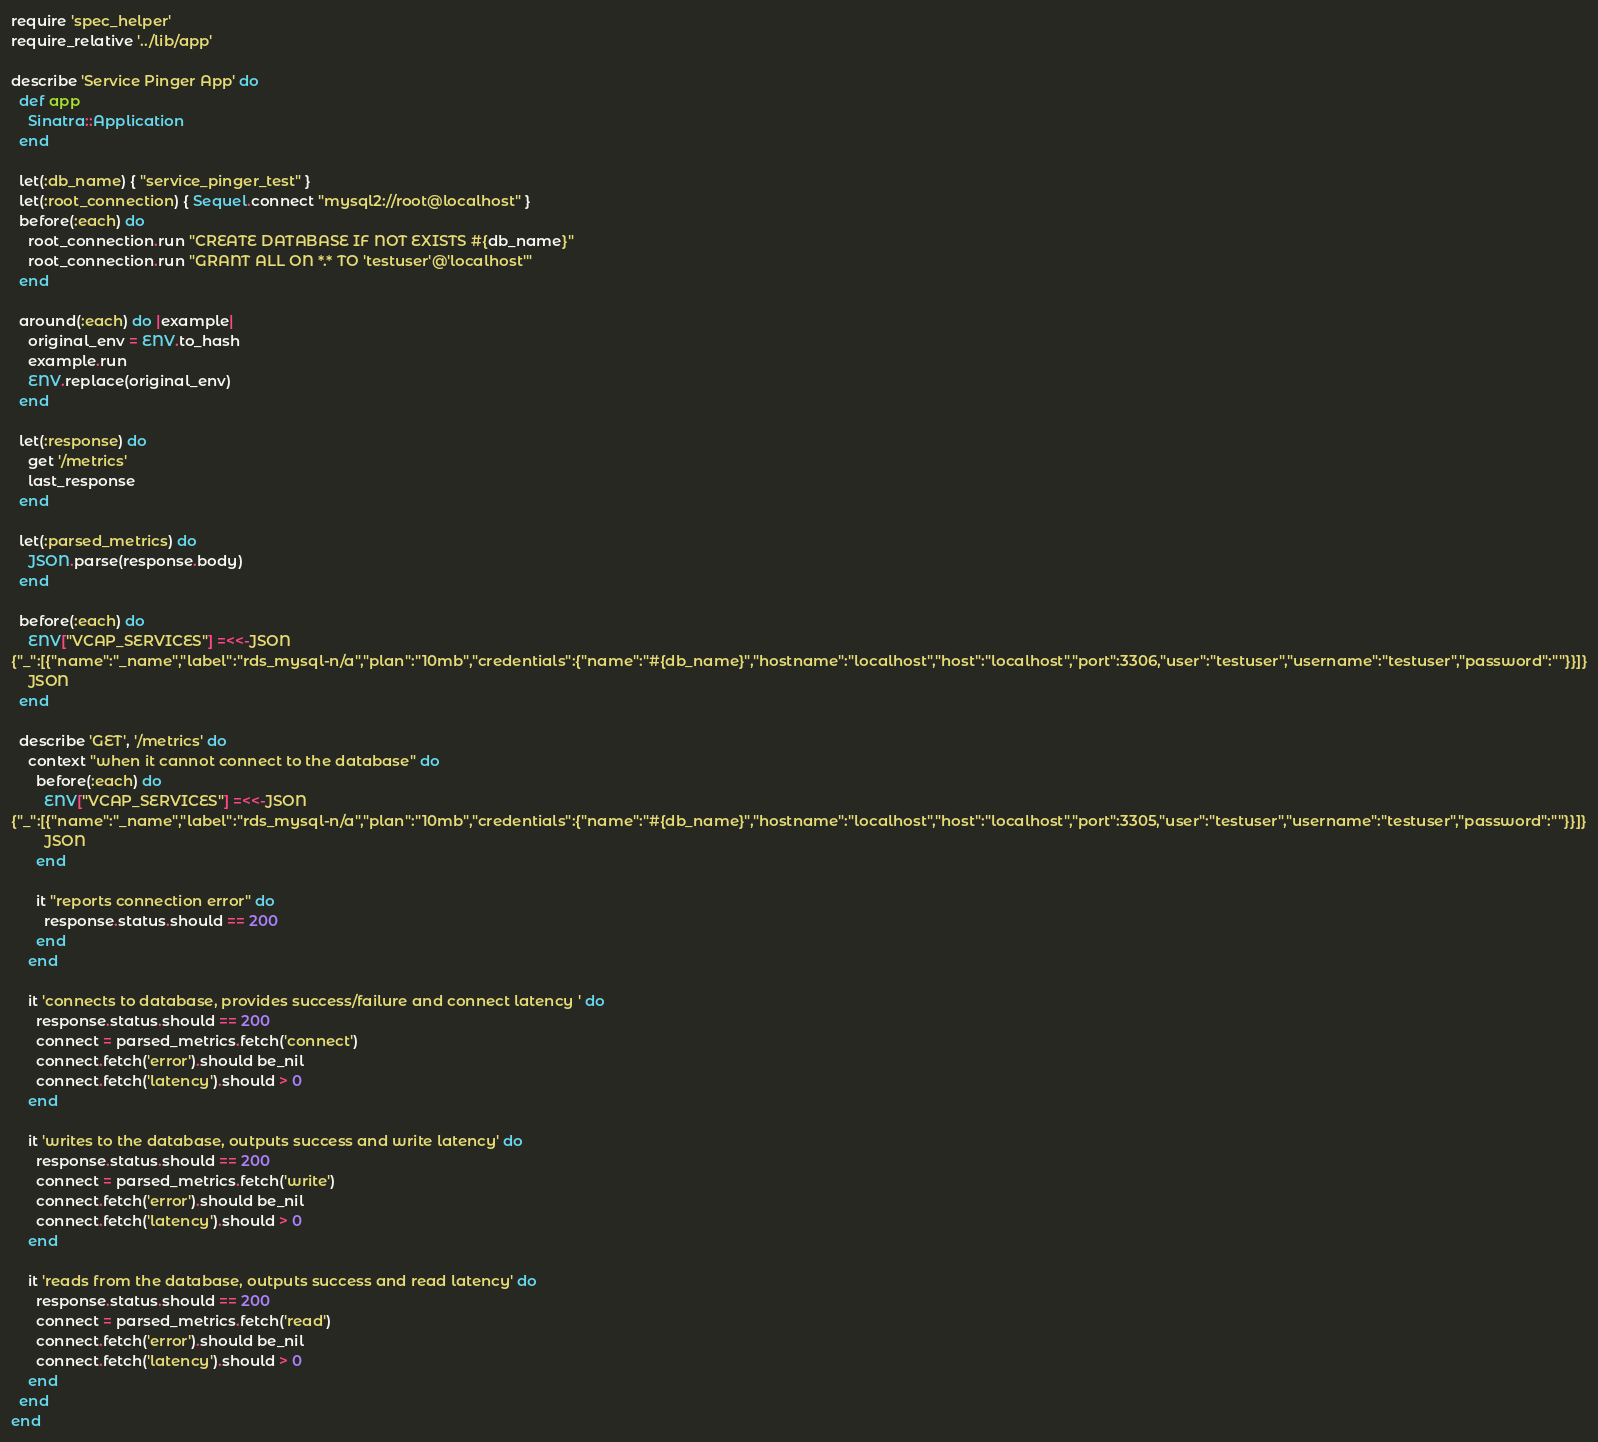Convert code to text. <code><loc_0><loc_0><loc_500><loc_500><_Ruby_>require 'spec_helper'
require_relative '../lib/app'

describe 'Service Pinger App' do
  def app
    Sinatra::Application
  end

  let(:db_name) { "service_pinger_test" }
  let(:root_connection) { Sequel.connect "mysql2://root@localhost" }
  before(:each) do
    root_connection.run "CREATE DATABASE IF NOT EXISTS #{db_name}"
    root_connection.run "GRANT ALL ON *.* TO 'testuser'@'localhost'"
  end

  around(:each) do |example|
    original_env = ENV.to_hash
    example.run
    ENV.replace(original_env)
  end

  let(:response) do
    get '/metrics'
    last_response
  end

  let(:parsed_metrics) do
    JSON.parse(response.body)
  end

  before(:each) do
    ENV["VCAP_SERVICES"] =<<-JSON
{"_":[{"name":"_name","label":"rds_mysql-n/a","plan":"10mb","credentials":{"name":"#{db_name}","hostname":"localhost","host":"localhost","port":3306,"user":"testuser","username":"testuser","password":""}}]}
    JSON
  end

  describe 'GET', '/metrics' do
    context "when it cannot connect to the database" do
      before(:each) do
        ENV["VCAP_SERVICES"] =<<-JSON
{"_":[{"name":"_name","label":"rds_mysql-n/a","plan":"10mb","credentials":{"name":"#{db_name}","hostname":"localhost","host":"localhost","port":3305,"user":"testuser","username":"testuser","password":""}}]}
        JSON
      end

      it "reports connection error" do
        response.status.should == 200
      end
    end

    it 'connects to database, provides success/failure and connect latency ' do
      response.status.should == 200
      connect = parsed_metrics.fetch('connect')
      connect.fetch('error').should be_nil
      connect.fetch('latency').should > 0
    end

    it 'writes to the database, outputs success and write latency' do
      response.status.should == 200
      connect = parsed_metrics.fetch('write')
      connect.fetch('error').should be_nil
      connect.fetch('latency').should > 0
    end

    it 'reads from the database, outputs success and read latency' do
      response.status.should == 200
      connect = parsed_metrics.fetch('read')
      connect.fetch('error').should be_nil
      connect.fetch('latency').should > 0
    end
  end
end
</code> 